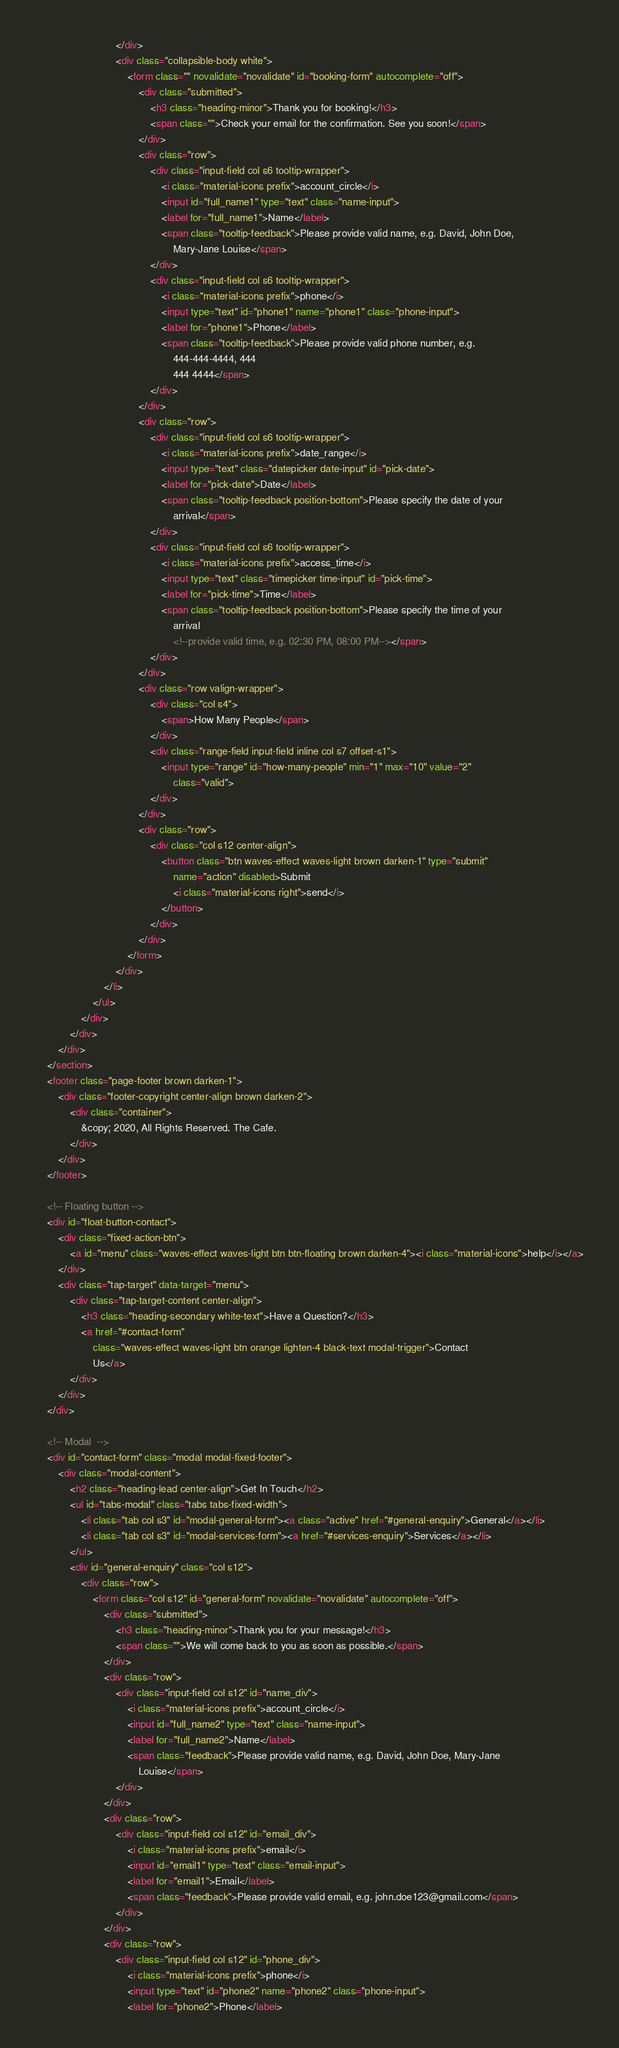Convert code to text. <code><loc_0><loc_0><loc_500><loc_500><_HTML_>                            </div>
                            <div class="collapsible-body white">
                                <form class="" novalidate="novalidate" id="booking-form" autocomplete="off">
                                    <div class="submitted">
                                        <h3 class="heading-minor">Thank you for booking!</h3>
                                        <span class="">Check your email for the confirmation. See you soon!</span>
                                    </div>
                                    <div class="row">
                                        <div class="input-field col s6 tooltip-wrapper">
                                            <i class="material-icons prefix">account_circle</i>
                                            <input id="full_name1" type="text" class="name-input">
                                            <label for="full_name1">Name</label>
                                            <span class="tooltip-feedback">Please provide valid name, e.g. David, John Doe,
                                                Mary-Jane Louise</span>
                                        </div>
                                        <div class="input-field col s6 tooltip-wrapper">
                                            <i class="material-icons prefix">phone</i>
                                            <input type="text" id="phone1" name="phone1" class="phone-input">
                                            <label for="phone1">Phone</label>
                                            <span class="tooltip-feedback">Please provide valid phone number, e.g.
                                                444-444-4444, 444
                                                444 4444</span>
                                        </div>
                                    </div>
                                    <div class="row">
                                        <div class="input-field col s6 tooltip-wrapper">
                                            <i class="material-icons prefix">date_range</i>
                                            <input type="text" class="datepicker date-input" id="pick-date">
                                            <label for="pick-date">Date</label>
                                            <span class="tooltip-feedback position-bottom">Please specify the date of your
                                                arrival</span>
                                        </div>
                                        <div class="input-field col s6 tooltip-wrapper">
                                            <i class="material-icons prefix">access_time</i>
                                            <input type="text" class="timepicker time-input" id="pick-time">
                                            <label for="pick-time">Time</label>
                                            <span class="tooltip-feedback position-bottom">Please specify the time of your
                                                arrival
                                                <!--provide valid time, e.g. 02:30 PM, 08:00 PM--></span>
                                        </div>
                                    </div>
                                    <div class="row valign-wrapper">
                                        <div class="col s4">
                                            <span>How Many People</span>
                                        </div>
                                        <div class="range-field input-field inline col s7 offset-s1">
                                            <input type="range" id="how-many-people" min="1" max="10" value="2"
                                                class="valid">
                                        </div>
                                    </div>
                                    <div class="row">
                                        <div class="col s12 center-align">
                                            <button class="btn waves-effect waves-light brown darken-1" type="submit"
                                                name="action" disabled>Submit
                                                <i class="material-icons right">send</i>
                                            </button>
                                        </div>
                                    </div>
                                </form>
                            </div>
                        </li>
                    </ul>
                </div>
            </div>
        </div>
    </section>
    <footer class="page-footer brown darken-1">
        <div class="footer-copyright center-align brown darken-2">
            <div class="container">
                &copy; 2020, All Rights Reserved. The Cafe.
            </div>
        </div>
    </footer>

    <!-- Floating button -->
    <div id="float-button-contact">
        <div class="fixed-action-btn">
            <a id="menu" class="waves-effect waves-light btn btn-floating brown darken-4"><i class="material-icons">help</i></a>
        </div>
        <div class="tap-target" data-target="menu">
            <div class="tap-target-content center-align">
                <h3 class="heading-secondary white-text">Have a Question?</h3>
                <a href="#contact-form"
                    class="waves-effect waves-light btn orange lighten-4 black-text modal-trigger">Contact
                    Us</a>
            </div>
        </div>
    </div>

    <!-- Modal  -->
    <div id="contact-form" class="modal modal-fixed-footer">
        <div class="modal-content">
            <h2 class="heading-lead center-align">Get In Touch</h2>
            <ul id="tabs-modal" class="tabs tabs-fixed-width">
                <li class="tab col s3" id="modal-general-form"><a class="active" href="#general-enquiry">General</a></li>
                <li class="tab col s3" id="modal-services-form"><a href="#services-enquiry">Services</a></li>
            </ul>
            <div id="general-enquiry" class="col s12">
                <div class="row">
                    <form class="col s12" id="general-form" novalidate="novalidate" autocomplete="off">
                        <div class="submitted">
                            <h3 class="heading-minor">Thank you for your message!</h3>
                            <span class="">We will come back to you as soon as possible.</span>
                        </div>
                        <div class="row">
                            <div class="input-field col s12" id="name_div">
                                <i class="material-icons prefix">account_circle</i>
                                <input id="full_name2" type="text" class="name-input">
                                <label for="full_name2">Name</label>
                                <span class="feedback">Please provide valid name, e.g. David, John Doe, Mary-Jane
                                    Louise</span>
                            </div>
                        </div>
                        <div class="row">
                            <div class="input-field col s12" id="email_div">
                                <i class="material-icons prefix">email</i>
                                <input id="email1" type="text" class="email-input">
                                <label for="email1">Email</label>
                                <span class="feedback">Please provide valid email, e.g. john.doe123@gmail.com</span>
                            </div>
                        </div>
                        <div class="row">
                            <div class="input-field col s12" id="phone_div">
                                <i class="material-icons prefix">phone</i>
                                <input type="text" id="phone2" name="phone2" class="phone-input">
                                <label for="phone2">Phone</label></code> 